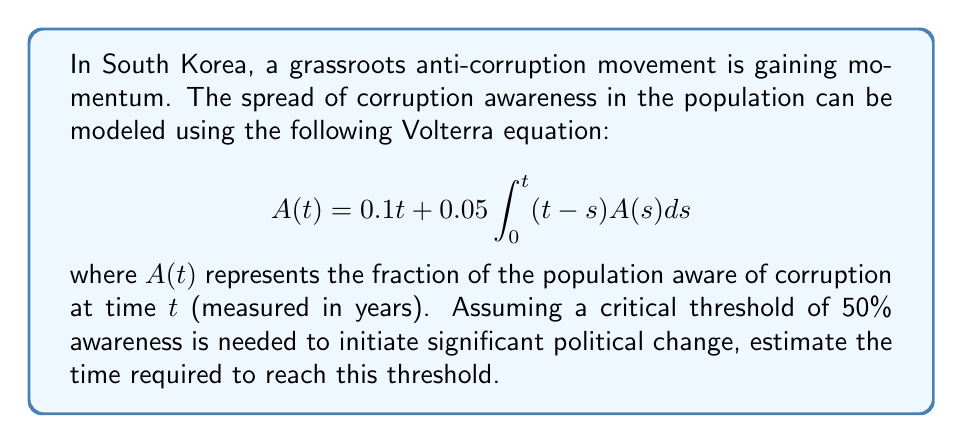What is the answer to this math problem? To solve this problem, we'll follow these steps:

1) First, we need to differentiate both sides of the equation with respect to $t$:

   $$\frac{dA}{dt} = 0.1 + 0.05 \int_0^t A(s)ds$$

2) Differentiating again:

   $$\frac{d^2A}{dt^2} = 0.05A(t)$$

3) This is a second-order linear differential equation. The general solution is:

   $$A(t) = c_1e^{\sqrt{0.05}t} + c_2e^{-\sqrt{0.05}t}$$

4) To find $c_1$ and $c_2$, we use the initial conditions:
   
   At $t=0$: $A(0) = 0.1 \cdot 0 = 0$
   At $t=0$: $\frac{dA}{dt}(0) = 0.1$

5) Applying these conditions:

   $0 = c_1 + c_2$
   $0.1 = \sqrt{0.05}(c_1 - c_2)$

6) Solving these equations:

   $c_1 = 0.1/(2\sqrt{0.05}) \approx 0.2236$
   $c_2 = -0.1/(2\sqrt{0.05}) \approx -0.2236$

7) Therefore, the solution is:

   $$A(t) = 0.2236(e^{\sqrt{0.05}t} - e^{-\sqrt{0.05}t})$$

8) To find when $A(t) = 0.5$ (50% awareness), we solve:

   $$0.5 = 0.2236(e^{\sqrt{0.05}t} - e^{-\sqrt{0.05}t})$$

9) This can be solved numerically to get $t \approx 8.76$ years.
Answer: 8.76 years 